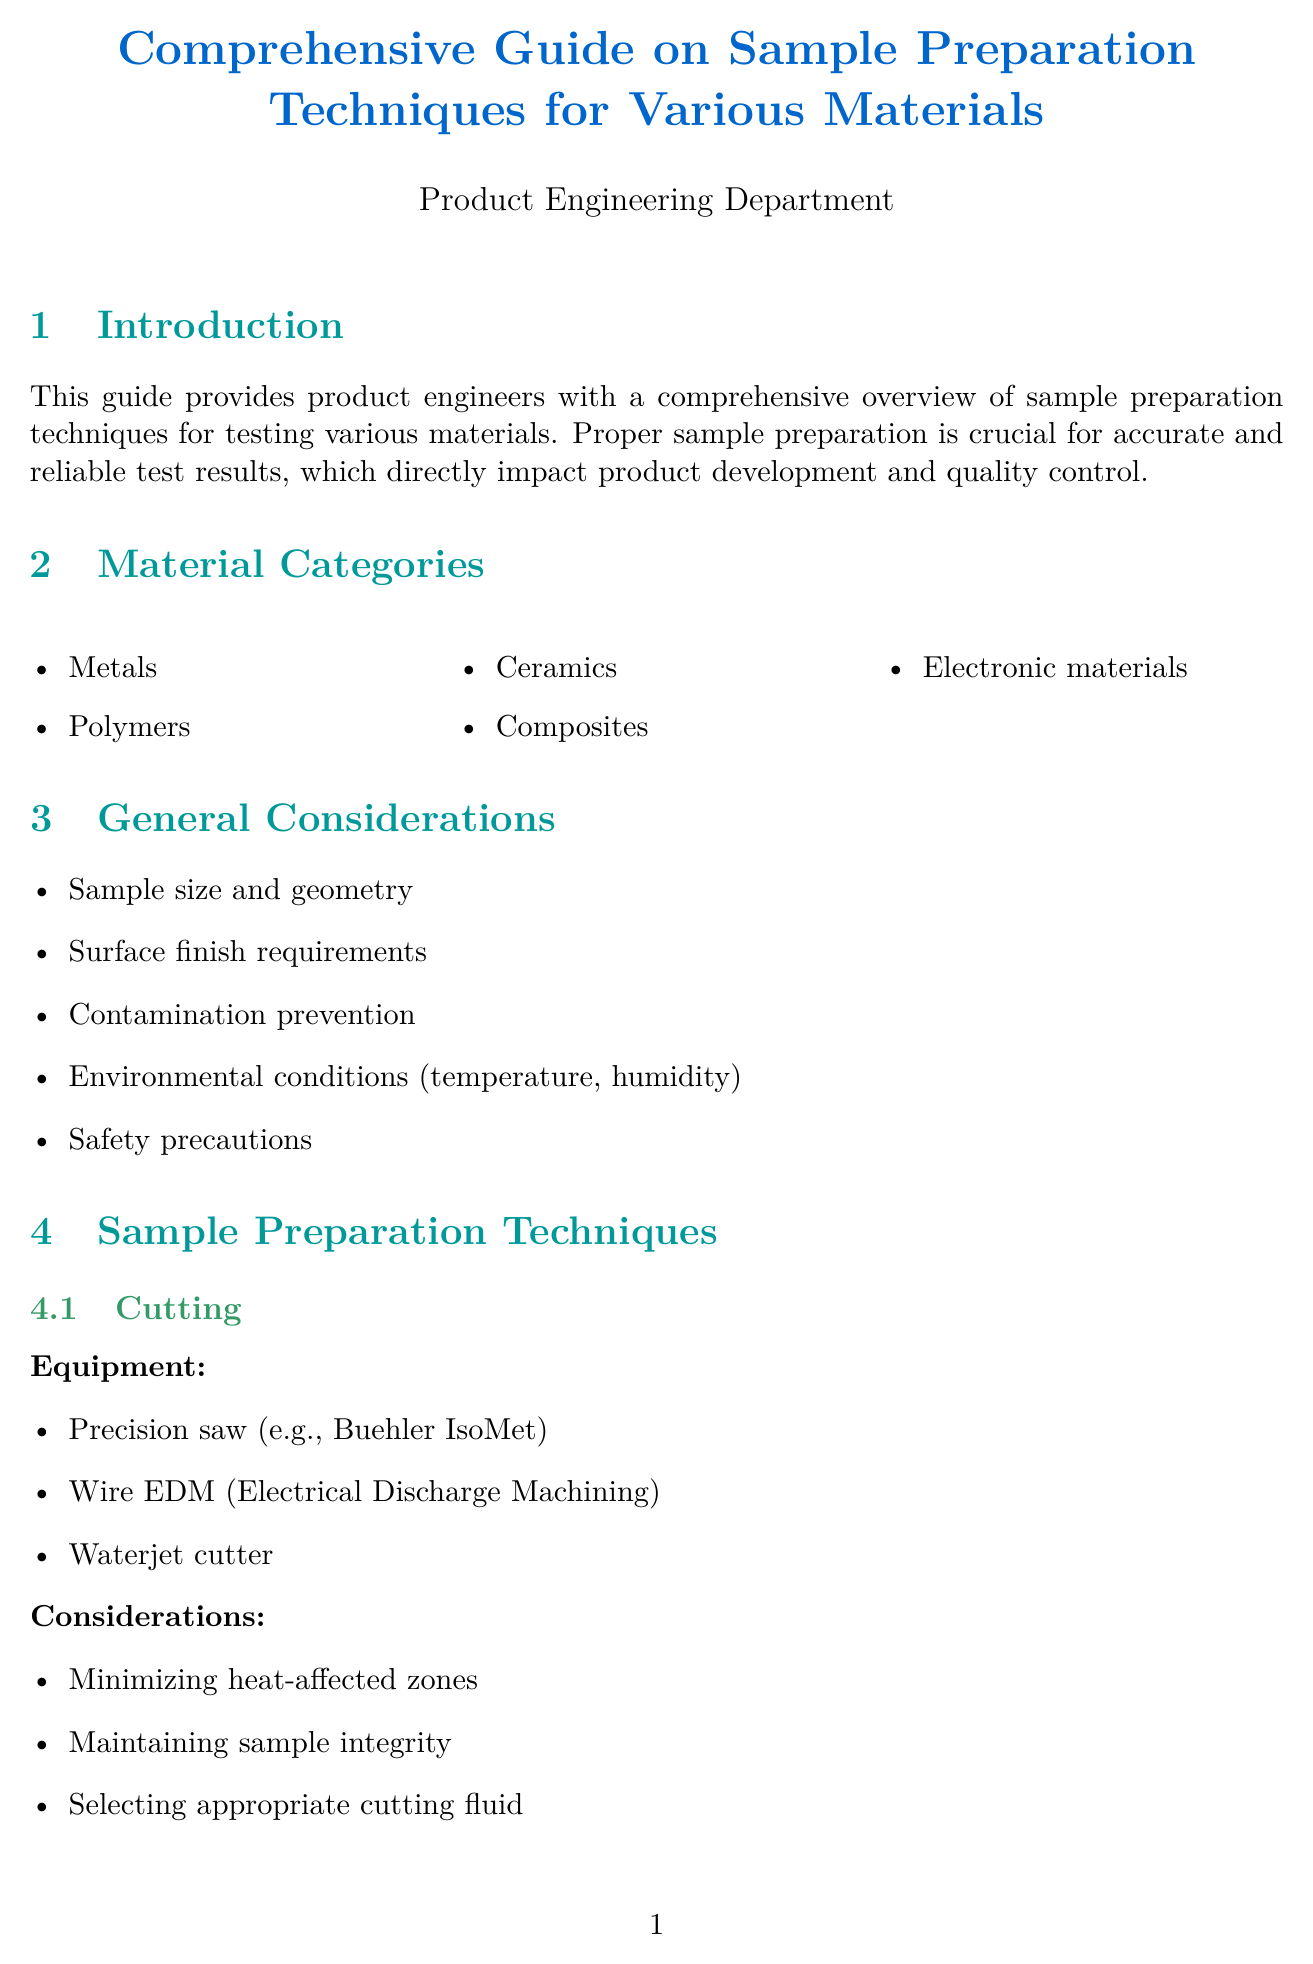what is the title of the document? The title of the document is presented at the beginning and is "Comprehensive Guide on Sample Preparation Techniques for Various Materials."
Answer: Comprehensive Guide on Sample Preparation Techniques for Various Materials how many material categories are listed? The document lists five material categories in the material categories section.
Answer: 5 which technique involves using a chemical etching solution? The sample preparation technique that involves using a chemical etching solution is etching.
Answer: Etching name one quality control method mentioned in the document. One quality control method mentioned is visual inspection.
Answer: Visual inspection what type of equipment is used for Grinding and Polishing? The document specifies several types of equipment for grinding and polishing, one of which is grinding wheels.
Answer: Grinding wheels what is a common issue during cutting? The document mentions sample deformation as a common issue during cutting.
Answer: Sample deformation which advanced technique uses the FEI Helios NanoLab DualBeam? The advanced technique that uses the FEI Helios NanoLab DualBeam is Focused Ion Beam.
Answer: Focused Ion Beam list one safety consideration mentioned in the document. One safety consideration mentioned is proper use of personal protective equipment (PPE).
Answer: Proper use of personal protective equipment (PPE) how is documentation maintained according to the guide? The guide states that documentation should include a sample ID and tracking system among other details.
Answer: Sample ID and tracking system 